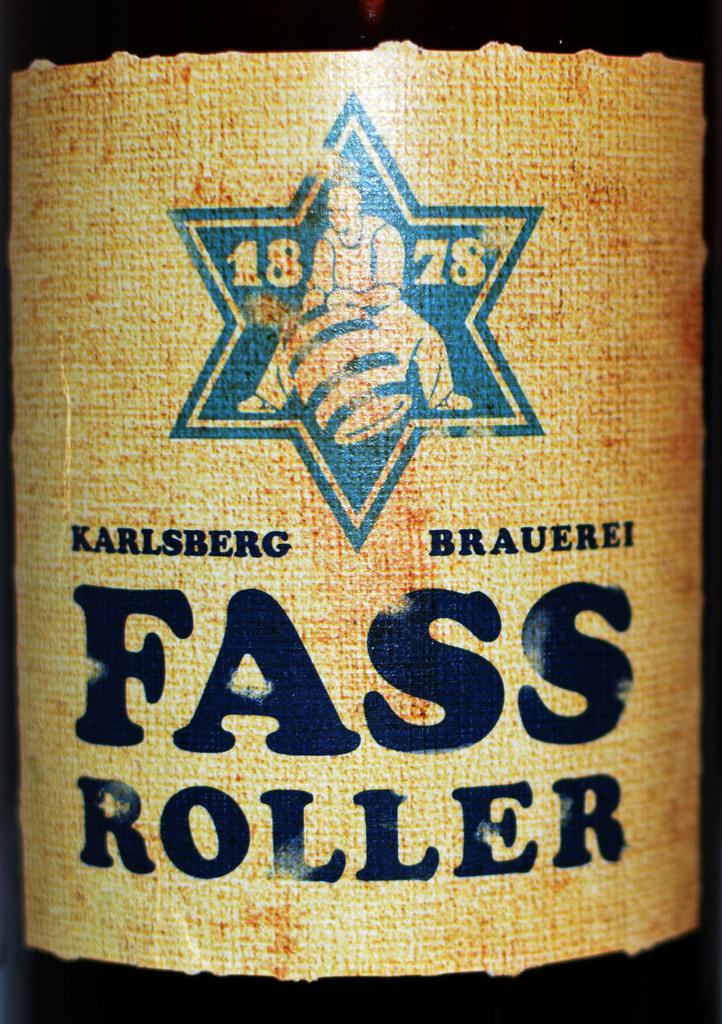<image>
Provide a brief description of the given image. An old label called Karlsberg Brauerei Fass Roller 